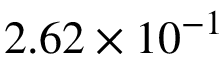Convert formula to latex. <formula><loc_0><loc_0><loc_500><loc_500>2 . 6 2 \times 1 0 ^ { - 1 }</formula> 